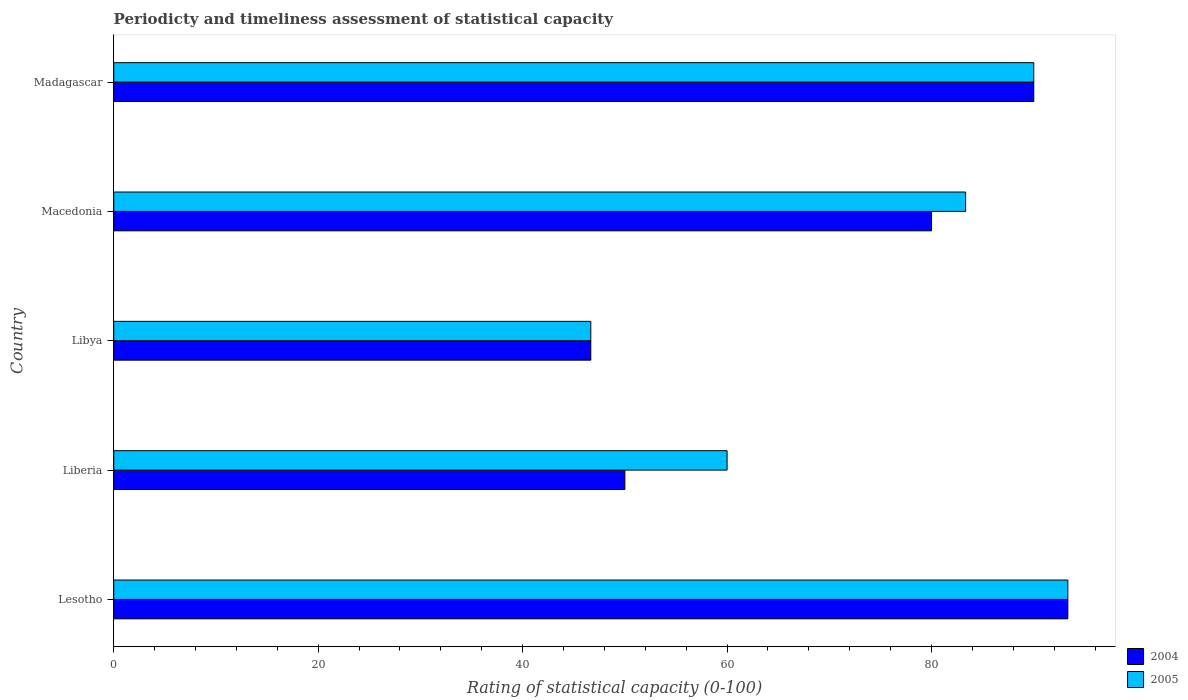What is the label of the 5th group of bars from the top?
Give a very brief answer. Lesotho. In how many cases, is the number of bars for a given country not equal to the number of legend labels?
Give a very brief answer. 0. Across all countries, what is the maximum rating of statistical capacity in 2005?
Provide a succinct answer. 93.33. Across all countries, what is the minimum rating of statistical capacity in 2004?
Give a very brief answer. 46.67. In which country was the rating of statistical capacity in 2004 maximum?
Your answer should be very brief. Lesotho. In which country was the rating of statistical capacity in 2005 minimum?
Keep it short and to the point. Libya. What is the total rating of statistical capacity in 2004 in the graph?
Ensure brevity in your answer.  360. What is the difference between the rating of statistical capacity in 2005 in Macedonia and that in Madagascar?
Your response must be concise. -6.67. What is the difference between the rating of statistical capacity in 2004 and rating of statistical capacity in 2005 in Libya?
Give a very brief answer. 0. In how many countries, is the rating of statistical capacity in 2004 greater than 16 ?
Give a very brief answer. 5. What is the ratio of the rating of statistical capacity in 2004 in Libya to that in Macedonia?
Give a very brief answer. 0.58. Is the rating of statistical capacity in 2004 in Lesotho less than that in Liberia?
Provide a succinct answer. No. What is the difference between the highest and the second highest rating of statistical capacity in 2005?
Offer a terse response. 3.33. What is the difference between the highest and the lowest rating of statistical capacity in 2005?
Your response must be concise. 46.67. In how many countries, is the rating of statistical capacity in 2004 greater than the average rating of statistical capacity in 2004 taken over all countries?
Provide a succinct answer. 3. Is the sum of the rating of statistical capacity in 2004 in Macedonia and Madagascar greater than the maximum rating of statistical capacity in 2005 across all countries?
Provide a short and direct response. Yes. What does the 2nd bar from the top in Lesotho represents?
Offer a terse response. 2004. What does the 1st bar from the bottom in Madagascar represents?
Give a very brief answer. 2004. Are all the bars in the graph horizontal?
Your answer should be compact. Yes. How many countries are there in the graph?
Your answer should be compact. 5. What is the difference between two consecutive major ticks on the X-axis?
Ensure brevity in your answer.  20. Are the values on the major ticks of X-axis written in scientific E-notation?
Keep it short and to the point. No. Does the graph contain grids?
Give a very brief answer. No. Where does the legend appear in the graph?
Your answer should be compact. Bottom right. How many legend labels are there?
Your answer should be very brief. 2. What is the title of the graph?
Offer a terse response. Periodicty and timeliness assessment of statistical capacity. Does "1991" appear as one of the legend labels in the graph?
Give a very brief answer. No. What is the label or title of the X-axis?
Your answer should be very brief. Rating of statistical capacity (0-100). What is the Rating of statistical capacity (0-100) in 2004 in Lesotho?
Offer a terse response. 93.33. What is the Rating of statistical capacity (0-100) in 2005 in Lesotho?
Provide a succinct answer. 93.33. What is the Rating of statistical capacity (0-100) in 2004 in Liberia?
Offer a very short reply. 50. What is the Rating of statistical capacity (0-100) of 2004 in Libya?
Provide a succinct answer. 46.67. What is the Rating of statistical capacity (0-100) of 2005 in Libya?
Your answer should be compact. 46.67. What is the Rating of statistical capacity (0-100) in 2004 in Macedonia?
Offer a very short reply. 80. What is the Rating of statistical capacity (0-100) of 2005 in Macedonia?
Ensure brevity in your answer.  83.33. What is the Rating of statistical capacity (0-100) in 2005 in Madagascar?
Give a very brief answer. 90. Across all countries, what is the maximum Rating of statistical capacity (0-100) in 2004?
Give a very brief answer. 93.33. Across all countries, what is the maximum Rating of statistical capacity (0-100) of 2005?
Your answer should be very brief. 93.33. Across all countries, what is the minimum Rating of statistical capacity (0-100) in 2004?
Provide a short and direct response. 46.67. Across all countries, what is the minimum Rating of statistical capacity (0-100) of 2005?
Keep it short and to the point. 46.67. What is the total Rating of statistical capacity (0-100) of 2004 in the graph?
Your answer should be very brief. 360. What is the total Rating of statistical capacity (0-100) of 2005 in the graph?
Make the answer very short. 373.33. What is the difference between the Rating of statistical capacity (0-100) of 2004 in Lesotho and that in Liberia?
Make the answer very short. 43.33. What is the difference between the Rating of statistical capacity (0-100) of 2005 in Lesotho and that in Liberia?
Offer a very short reply. 33.33. What is the difference between the Rating of statistical capacity (0-100) of 2004 in Lesotho and that in Libya?
Provide a succinct answer. 46.67. What is the difference between the Rating of statistical capacity (0-100) of 2005 in Lesotho and that in Libya?
Provide a short and direct response. 46.67. What is the difference between the Rating of statistical capacity (0-100) in 2004 in Lesotho and that in Macedonia?
Your response must be concise. 13.33. What is the difference between the Rating of statistical capacity (0-100) in 2004 in Lesotho and that in Madagascar?
Keep it short and to the point. 3.33. What is the difference between the Rating of statistical capacity (0-100) in 2005 in Lesotho and that in Madagascar?
Provide a short and direct response. 3.33. What is the difference between the Rating of statistical capacity (0-100) in 2005 in Liberia and that in Libya?
Your answer should be compact. 13.33. What is the difference between the Rating of statistical capacity (0-100) of 2005 in Liberia and that in Macedonia?
Ensure brevity in your answer.  -23.33. What is the difference between the Rating of statistical capacity (0-100) of 2005 in Liberia and that in Madagascar?
Ensure brevity in your answer.  -30. What is the difference between the Rating of statistical capacity (0-100) in 2004 in Libya and that in Macedonia?
Make the answer very short. -33.33. What is the difference between the Rating of statistical capacity (0-100) of 2005 in Libya and that in Macedonia?
Offer a terse response. -36.67. What is the difference between the Rating of statistical capacity (0-100) in 2004 in Libya and that in Madagascar?
Your answer should be very brief. -43.33. What is the difference between the Rating of statistical capacity (0-100) in 2005 in Libya and that in Madagascar?
Make the answer very short. -43.33. What is the difference between the Rating of statistical capacity (0-100) in 2005 in Macedonia and that in Madagascar?
Ensure brevity in your answer.  -6.67. What is the difference between the Rating of statistical capacity (0-100) in 2004 in Lesotho and the Rating of statistical capacity (0-100) in 2005 in Liberia?
Make the answer very short. 33.33. What is the difference between the Rating of statistical capacity (0-100) in 2004 in Lesotho and the Rating of statistical capacity (0-100) in 2005 in Libya?
Offer a very short reply. 46.67. What is the difference between the Rating of statistical capacity (0-100) in 2004 in Liberia and the Rating of statistical capacity (0-100) in 2005 in Macedonia?
Ensure brevity in your answer.  -33.33. What is the difference between the Rating of statistical capacity (0-100) in 2004 in Libya and the Rating of statistical capacity (0-100) in 2005 in Macedonia?
Make the answer very short. -36.67. What is the difference between the Rating of statistical capacity (0-100) in 2004 in Libya and the Rating of statistical capacity (0-100) in 2005 in Madagascar?
Keep it short and to the point. -43.33. What is the average Rating of statistical capacity (0-100) in 2004 per country?
Offer a very short reply. 72. What is the average Rating of statistical capacity (0-100) in 2005 per country?
Keep it short and to the point. 74.67. What is the difference between the Rating of statistical capacity (0-100) of 2004 and Rating of statistical capacity (0-100) of 2005 in Libya?
Offer a very short reply. 0. What is the ratio of the Rating of statistical capacity (0-100) in 2004 in Lesotho to that in Liberia?
Offer a terse response. 1.87. What is the ratio of the Rating of statistical capacity (0-100) of 2005 in Lesotho to that in Liberia?
Your response must be concise. 1.56. What is the ratio of the Rating of statistical capacity (0-100) in 2005 in Lesotho to that in Libya?
Ensure brevity in your answer.  2. What is the ratio of the Rating of statistical capacity (0-100) in 2004 in Lesotho to that in Macedonia?
Provide a succinct answer. 1.17. What is the ratio of the Rating of statistical capacity (0-100) in 2005 in Lesotho to that in Macedonia?
Your answer should be compact. 1.12. What is the ratio of the Rating of statistical capacity (0-100) of 2004 in Lesotho to that in Madagascar?
Offer a very short reply. 1.04. What is the ratio of the Rating of statistical capacity (0-100) of 2004 in Liberia to that in Libya?
Keep it short and to the point. 1.07. What is the ratio of the Rating of statistical capacity (0-100) in 2005 in Liberia to that in Libya?
Keep it short and to the point. 1.29. What is the ratio of the Rating of statistical capacity (0-100) in 2005 in Liberia to that in Macedonia?
Your response must be concise. 0.72. What is the ratio of the Rating of statistical capacity (0-100) in 2004 in Liberia to that in Madagascar?
Keep it short and to the point. 0.56. What is the ratio of the Rating of statistical capacity (0-100) in 2004 in Libya to that in Macedonia?
Give a very brief answer. 0.58. What is the ratio of the Rating of statistical capacity (0-100) of 2005 in Libya to that in Macedonia?
Your response must be concise. 0.56. What is the ratio of the Rating of statistical capacity (0-100) of 2004 in Libya to that in Madagascar?
Ensure brevity in your answer.  0.52. What is the ratio of the Rating of statistical capacity (0-100) in 2005 in Libya to that in Madagascar?
Offer a terse response. 0.52. What is the ratio of the Rating of statistical capacity (0-100) of 2004 in Macedonia to that in Madagascar?
Offer a very short reply. 0.89. What is the ratio of the Rating of statistical capacity (0-100) of 2005 in Macedonia to that in Madagascar?
Your response must be concise. 0.93. What is the difference between the highest and the second highest Rating of statistical capacity (0-100) in 2004?
Offer a very short reply. 3.33. What is the difference between the highest and the lowest Rating of statistical capacity (0-100) in 2004?
Offer a terse response. 46.67. What is the difference between the highest and the lowest Rating of statistical capacity (0-100) in 2005?
Make the answer very short. 46.67. 